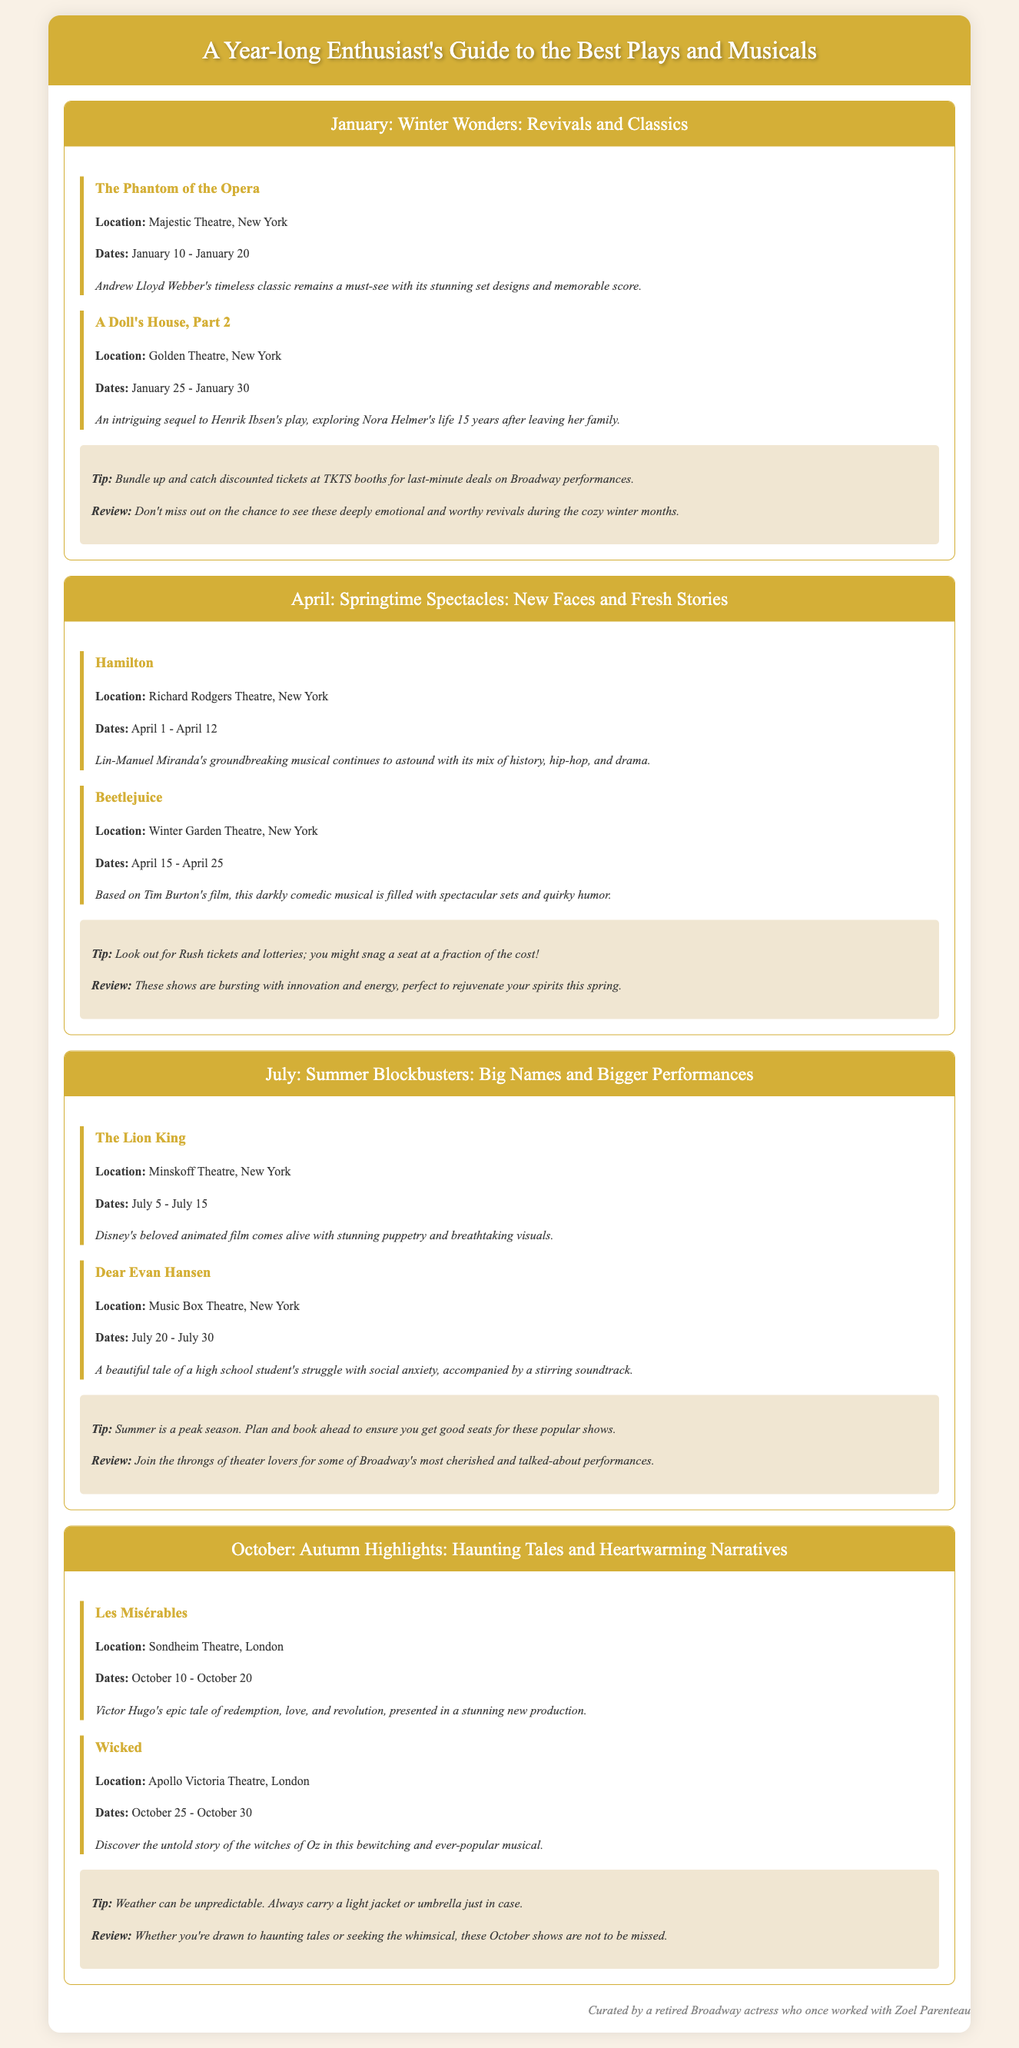What is the title of the first event in January? The first event in January is titled "The Phantom of the Opera."
Answer: The Phantom of the Opera Where is "A Doll's House, Part 2" being performed? "A Doll's House, Part 2" is being performed at the Golden Theatre, New York.
Answer: Golden Theatre, New York How many events are listed for April? There are two events listed for April: "Hamilton" and "Beetlejuice."
Answer: 2 What dates does "Les Misérables" run in October? "Les Misérables" runs from October 10 to October 20.
Answer: October 10 - October 20 What is the recommendation tip for July? The recommendation tip for July advises to plan and book ahead.
Answer: Plan and book ahead What is the overarching theme of the events listed in October? The overarching theme for October events revolves around haunting tales and heartwarming narratives.
Answer: Haunting tales and heartwarming narratives Which musical features a story about a high school student's struggle? The musical "Dear Evan Hansen" features a story about a high school student's struggle.
Answer: Dear Evan Hansen What is the name of the theater where "Hamilton" is performed? "Hamilton" is performed at the Richard Rodgers Theatre, New York.
Answer: Richard Rodgers Theatre, New York What is a suggested way to find discounted tickets in January? A suggested way to find discounted tickets in January is to check TKTS booths for last-minute deals.
Answer: TKTS booths for last-minute deals 